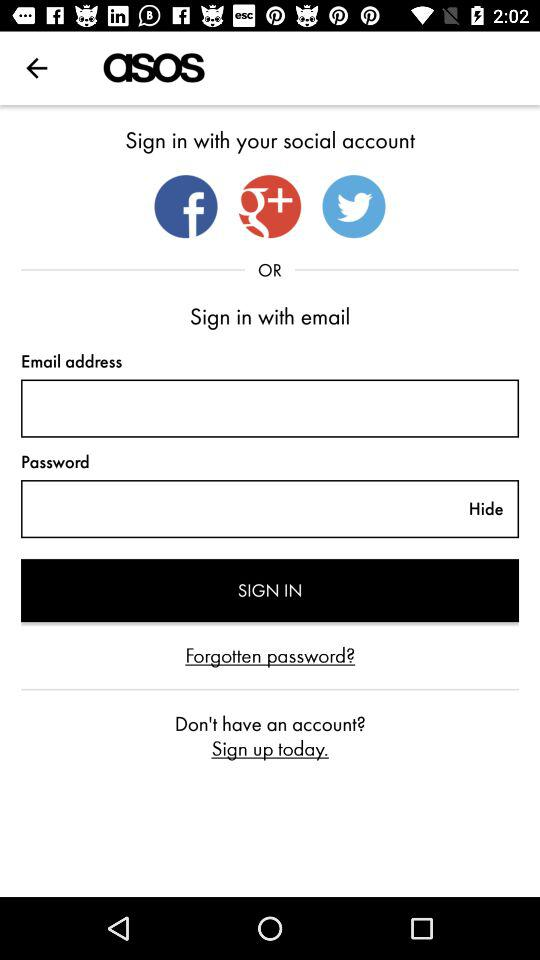What are the apps that can be used to sign in? The applications are: "Facebook", "Google+", and "Twitter". 